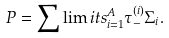Convert formula to latex. <formula><loc_0><loc_0><loc_500><loc_500>P = \sum \lim i t s _ { i = 1 } ^ { A } \tau _ { - } ^ { ( i ) } { \Sigma } _ { i } .</formula> 